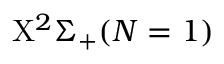Convert formula to latex. <formula><loc_0><loc_0><loc_500><loc_500>X ^ { 2 } \Sigma _ { + } ( N = 1 )</formula> 